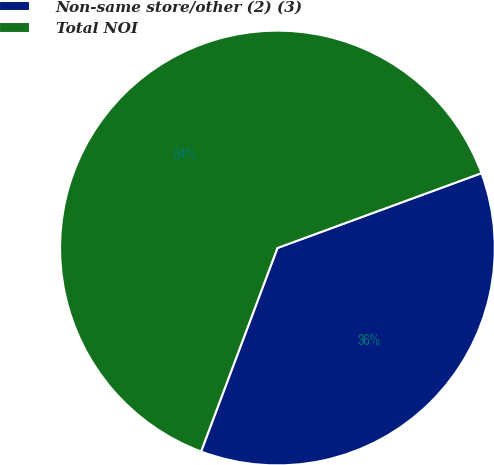Convert chart to OTSL. <chart><loc_0><loc_0><loc_500><loc_500><pie_chart><fcel>Non-same store/other (2) (3)<fcel>Total NOI<nl><fcel>36.31%<fcel>63.69%<nl></chart> 